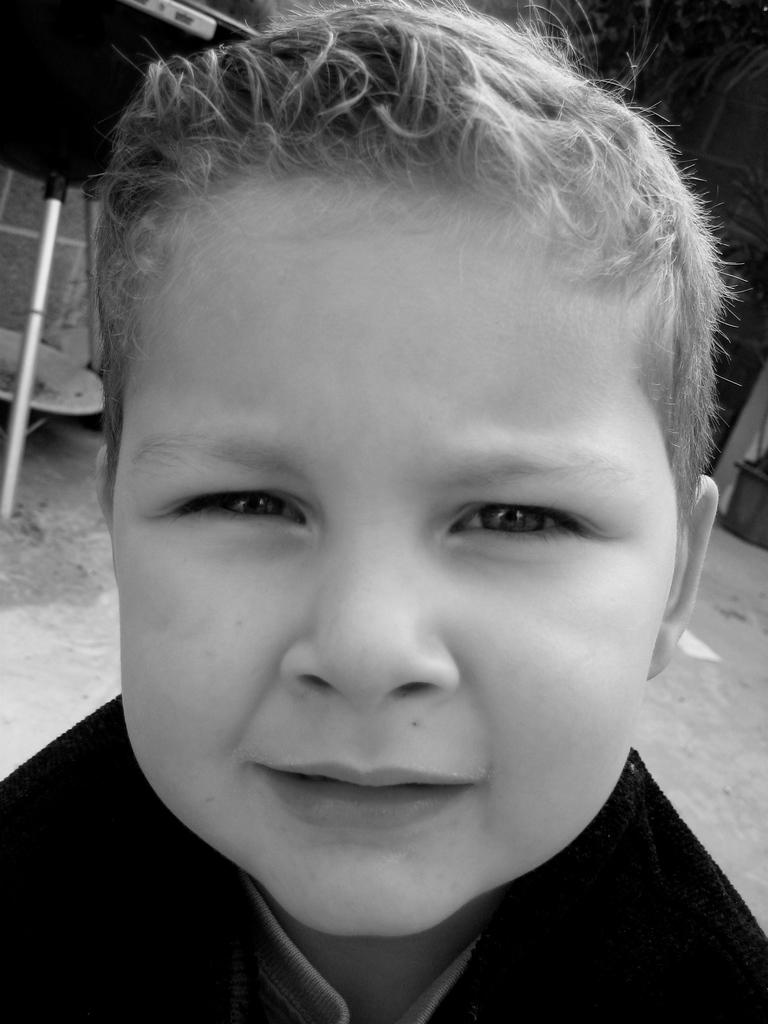What is the color scheme of the picture? The picture is black and white. Who or what is the main subject in the picture? There is a boy in the picture. What can be seen in the background of the picture? There are objects in the background of the picture. What type of potato is being discussed by the committee in the image? There is no committee or potato present in the image; it features a boy and objects in the background. What grain is being used to make the bread in the image? There is no bread or grain present in the image. 